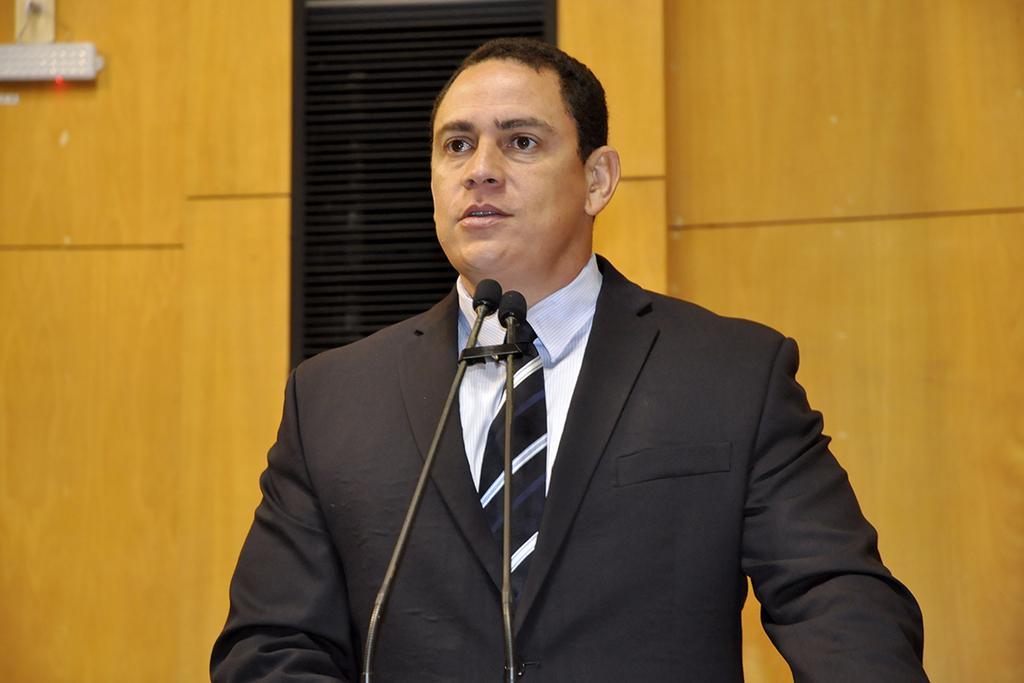Describe this image in one or two sentences. In this image we can see a person wearing suit and standing in front of the mics. 